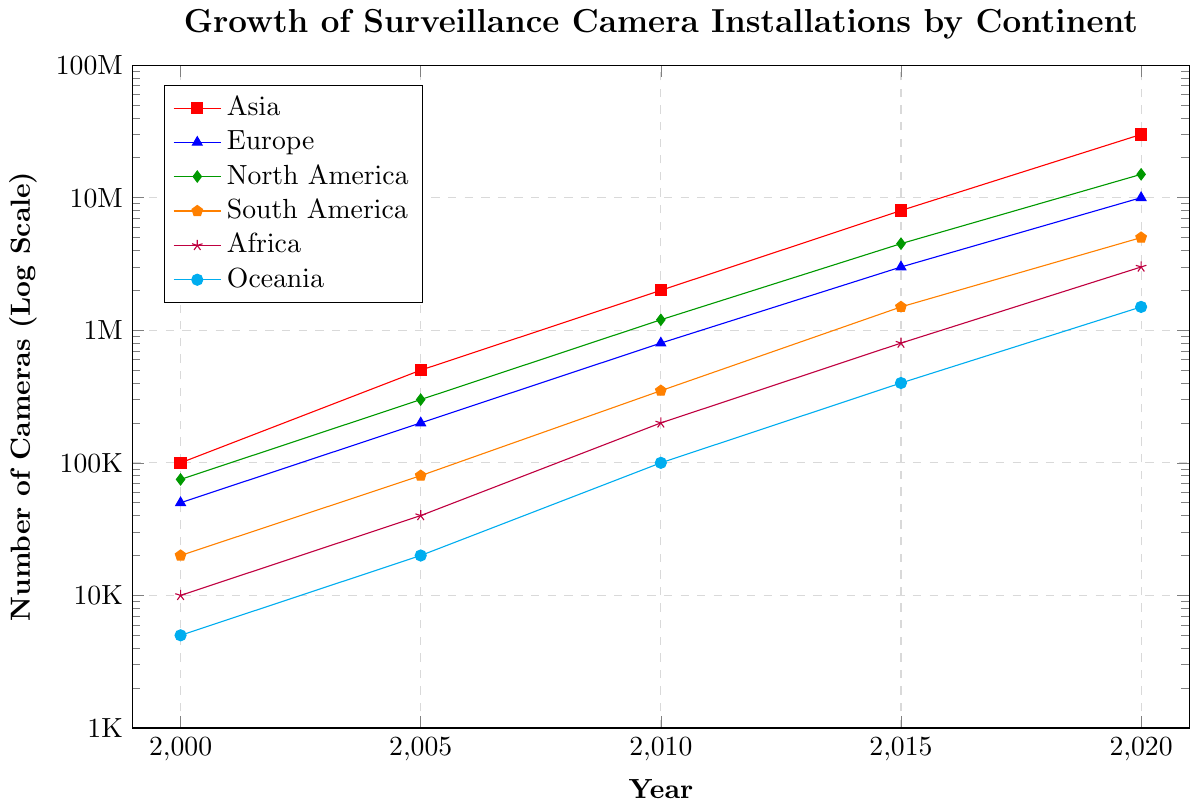Which continent saw the highest growth in the number of surveillance cameras from 2000 to 2020? Asia saw the highest growth. The number of cameras increased from 100,000 in 2000 to 30,000,000 in 2020. This is the most significant increase compared to the other continents.
Answer: Asia Between North America and Europe, which continent had more surveillance cameras in 2010? According to the figure, North America had 1,200,000 cameras in 2010, while Europe had 800,000. Thus, North America had more cameras.
Answer: North America What is the difference in the number of surveillance cameras between South America and Oceania in 2020? In 2020, South America had 5,000,000 cameras, and Oceania had 1,500,000 cameras. The difference is 5,000,000 - 1,500,000 = 3,500,000 cameras.
Answer: 3,500,000 How much did the number of cameras increase in Africa from 2000 to 2020? In 2000, Africa had 10,000 cameras and in 2020, it had 3,000,000. The increase is 3,000,000 - 10,000 = 2,990,000 cameras.
Answer: 2,990,000 What is the average number of cameras installed in Europe across the years 2000, 2005, 2010, 2015, and 2020? The numbers for Europe are: 50,000 in 2000, 200,000 in 2005, 800,000 in 2010, 3,000,000 in 2015 and 10,000,000 in 2020. Their sum is 50,000 + 200,000 + 800,000 + 3,000,000 + 10,000,000 = 14,050,000. Dividing by 5 gives 2,810,000.
Answer: 2,810,000 Which continent had the least growth in the number of cameras from 2000 to 2020? Oceania had the lowest growth, starting from 5,000 cameras in 2000 to 1,500,000 in 2020. The increase was 1,495,000, which is the smallest compared to the other continents.
Answer: Oceania Which continent had a steeper increase in the number of cameras between 2010 and 2015, Asia or Europe? Between 2010 and 2015, Asia's cameras increased from 2,000,000 to 8,000,000 (a difference of 6,000,000), while Europe's increased from 800,000 to 3,000,000 (a difference of 2,200,000). Asia had a steeper increase.
Answer: Asia 